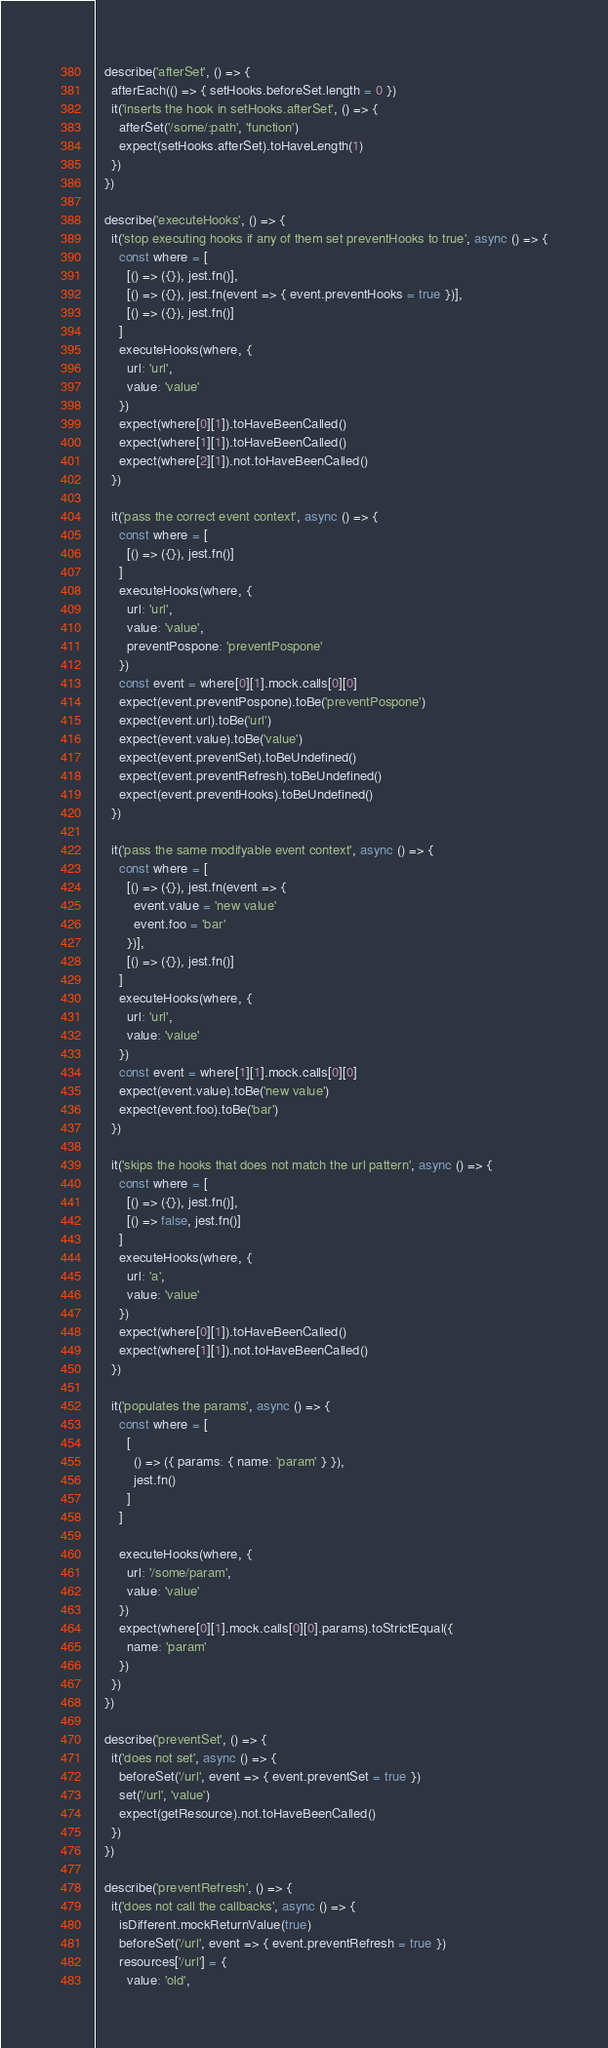Convert code to text. <code><loc_0><loc_0><loc_500><loc_500><_JavaScript_>
  describe('afterSet', () => {
    afterEach(() => { setHooks.beforeSet.length = 0 })
    it('inserts the hook in setHooks.afterSet', () => {
      afterSet('/some/:path', 'function')
      expect(setHooks.afterSet).toHaveLength(1)
    })
  })

  describe('executeHooks', () => {
    it('stop executing hooks if any of them set preventHooks to true', async () => {
      const where = [
        [() => ({}), jest.fn()],
        [() => ({}), jest.fn(event => { event.preventHooks = true })],
        [() => ({}), jest.fn()]
      ]
      executeHooks(where, {
        url: 'url',
        value: 'value'
      })
      expect(where[0][1]).toHaveBeenCalled()
      expect(where[1][1]).toHaveBeenCalled()
      expect(where[2][1]).not.toHaveBeenCalled()
    })

    it('pass the correct event context', async () => {
      const where = [
        [() => ({}), jest.fn()]
      ]
      executeHooks(where, {
        url: 'url',
        value: 'value',
        preventPospone: 'preventPospone'
      })
      const event = where[0][1].mock.calls[0][0]
      expect(event.preventPospone).toBe('preventPospone')
      expect(event.url).toBe('url')
      expect(event.value).toBe('value')
      expect(event.preventSet).toBeUndefined()
      expect(event.preventRefresh).toBeUndefined()
      expect(event.preventHooks).toBeUndefined()
    })

    it('pass the same modifyable event context', async () => {
      const where = [
        [() => ({}), jest.fn(event => {
          event.value = 'new value'
          event.foo = 'bar'
        })],
        [() => ({}), jest.fn()]
      ]
      executeHooks(where, {
        url: 'url',
        value: 'value'
      })
      const event = where[1][1].mock.calls[0][0]
      expect(event.value).toBe('new value')
      expect(event.foo).toBe('bar')
    })

    it('skips the hooks that does not match the url pattern', async () => {
      const where = [
        [() => ({}), jest.fn()],
        [() => false, jest.fn()]
      ]
      executeHooks(where, {
        url: 'a',
        value: 'value'
      })
      expect(where[0][1]).toHaveBeenCalled()
      expect(where[1][1]).not.toHaveBeenCalled()
    })

    it('populates the params', async () => {
      const where = [
        [
          () => ({ params: { name: 'param' } }),
          jest.fn()
        ]
      ]

      executeHooks(where, {
        url: '/some/param',
        value: 'value'
      })
      expect(where[0][1].mock.calls[0][0].params).toStrictEqual({
        name: 'param'
      })
    })
  })

  describe('preventSet', () => {
    it('does not set', async () => {
      beforeSet('/url', event => { event.preventSet = true })
      set('/url', 'value')
      expect(getResource).not.toHaveBeenCalled()
    })
  })

  describe('preventRefresh', () => {
    it('does not call the callbacks', async () => {
      isDifferent.mockReturnValue(true)
      beforeSet('/url', event => { event.preventRefresh = true })
      resources['/url'] = {
        value: 'old',</code> 